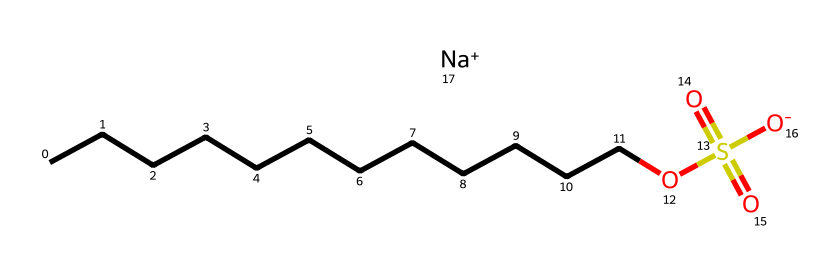What is the total number of carbon atoms in sodium lauryl sulfate? By analyzing the SMILES representation, we see "CCCCCCCCCCCC" indicates a straight chain of 12 carbon atoms.
Answer: 12 What does "O" in the SMILES represent? The "O" in the SMILES represents oxygen atoms; there are 2 oxygen atoms in the sulfate group and 1 in the alkyl chain.
Answer: oxygen How many sulfur atoms are present in this chemical structure? The "S" in the SMILES indicates the presence of one sulfur atom in the sulfate group, which is connected to the oxygen atoms.
Answer: 1 What type of functional group is present at the end of the sodium lauryl sulfate structure? The presence of "OS(=O)(=O)[O-]" indicates a sulfate functional group at the end of the carbon chain.
Answer: sulfate What is the charge on the sodium ion in this structure? Looking at the "[Na+]", the "+" signifies that the sodium ion carries a positive charge.
Answer: positive How many total oxygen atoms are present in the sodium lauryl sulfate molecule? The structure shows a total of 4 oxygen atoms: one in the alkyl chain, and three in the sulfate part (OS(=O)(=O)[O-]).
Answer: 4 What type of detergent is sodium lauryl sulfate? Sodium lauryl sulfate is classified as an anionic detergent, due to its negative charge on the sulfate group when dissociated in solution.
Answer: anionic 